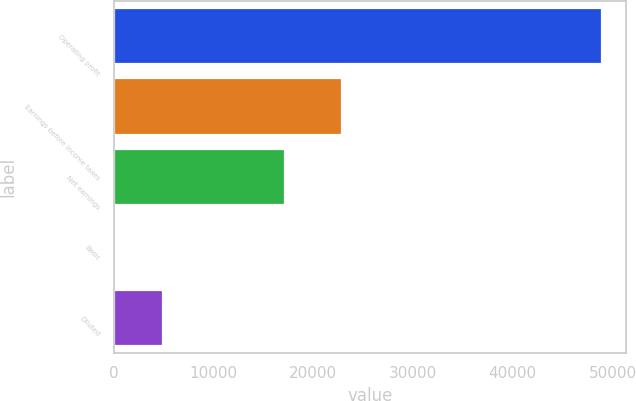<chart> <loc_0><loc_0><loc_500><loc_500><bar_chart><fcel>Operating profit<fcel>Earnings before income taxes<fcel>Net earnings<fcel>Basic<fcel>Diluted<nl><fcel>48923<fcel>22838<fcel>17196<fcel>0.12<fcel>4892.41<nl></chart> 